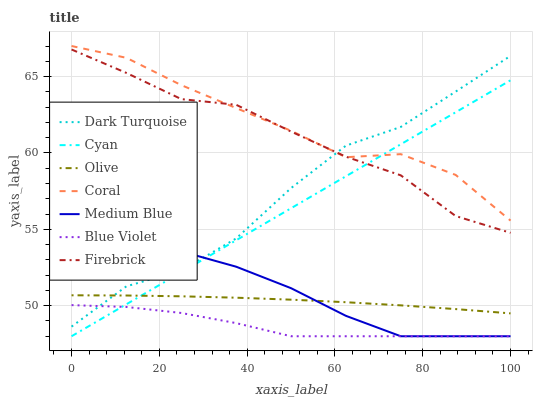Does Blue Violet have the minimum area under the curve?
Answer yes or no. Yes. Does Medium Blue have the minimum area under the curve?
Answer yes or no. No. Does Medium Blue have the maximum area under the curve?
Answer yes or no. No. Is Coral the smoothest?
Answer yes or no. No. Is Coral the roughest?
Answer yes or no. No. Does Coral have the lowest value?
Answer yes or no. No. Does Medium Blue have the highest value?
Answer yes or no. No. Is Olive less than Firebrick?
Answer yes or no. Yes. Is Dark Turquoise greater than Cyan?
Answer yes or no. Yes. Does Olive intersect Firebrick?
Answer yes or no. No. 